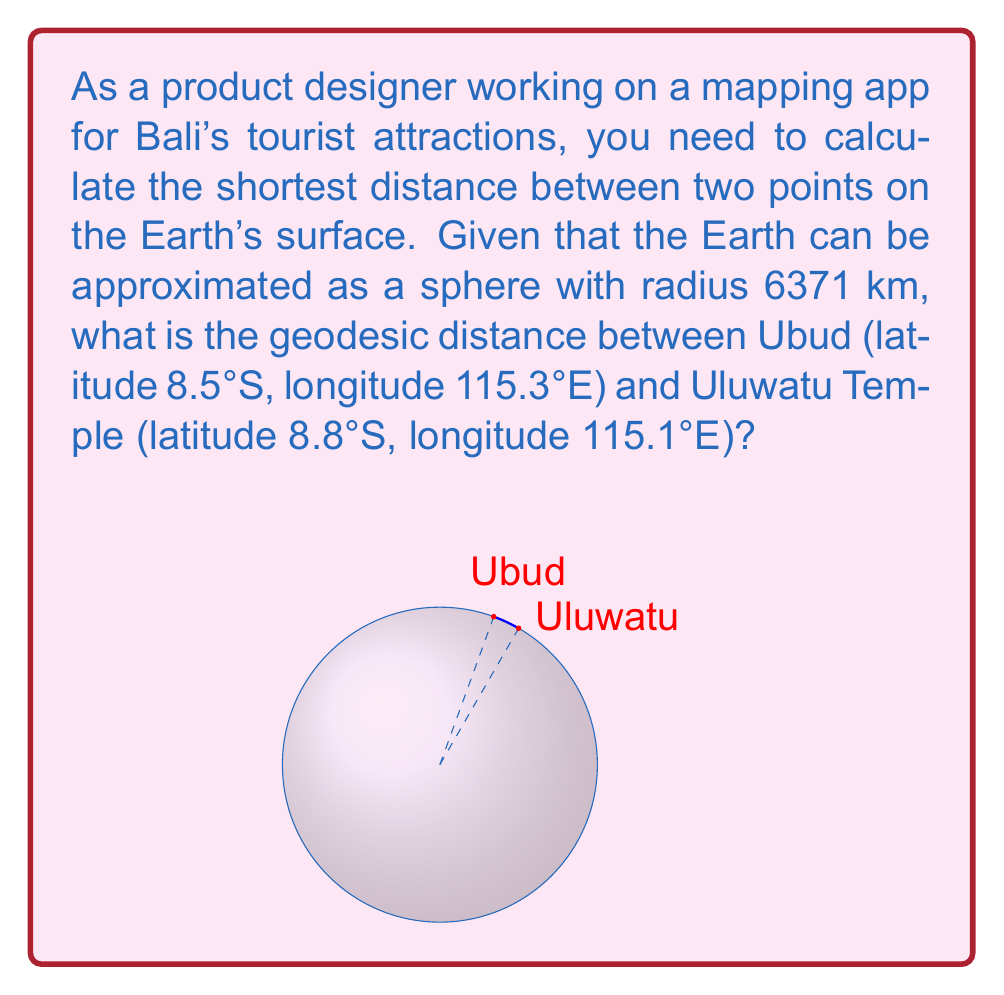Give your solution to this math problem. To solve this problem, we'll use the spherical law of cosines to calculate the central angle between the two points, then multiply by the Earth's radius to get the geodesic distance.

Step 1: Convert latitudes and longitudes to radians.
$\phi_1 = -8.5° \times \frac{\pi}{180°} = -0.1484$ rad
$\lambda_1 = 115.3° \times \frac{\pi}{180°} = 2.0122$ rad
$\phi_2 = -8.8° \times \frac{\pi}{180°} = -0.1536$ rad
$\lambda_2 = 115.1° \times \frac{\pi}{180°} = 2.0087$ rad

Step 2: Calculate the central angle $\Delta\sigma$ using the spherical law of cosines:
$$\Delta\sigma = \arccos(\sin\phi_1 \sin\phi_2 + \cos\phi_1 \cos\phi_2 \cos(\lambda_2 - \lambda_1))$$

Substituting the values:
$$\Delta\sigma = \arccos(\sin(-0.1484) \sin(-0.1536) + \cos(-0.1484) \cos(-0.1536) \cos(2.0087 - 2.0122))$$
$$\Delta\sigma = \arccos(0.9999916)$$
$$\Delta\sigma = 0.00410 \text{ rad}$$

Step 3: Calculate the geodesic distance $d$ by multiplying the central angle by the Earth's radius:
$$d = R \times \Delta\sigma$$
$$d = 6371 \text{ km} \times 0.00410 \text{ rad}$$
$$d = 26.12 \text{ km}$$

Therefore, the geodesic distance between Ubud and Uluwatu Temple is approximately 26.12 km.
Answer: 26.12 km 